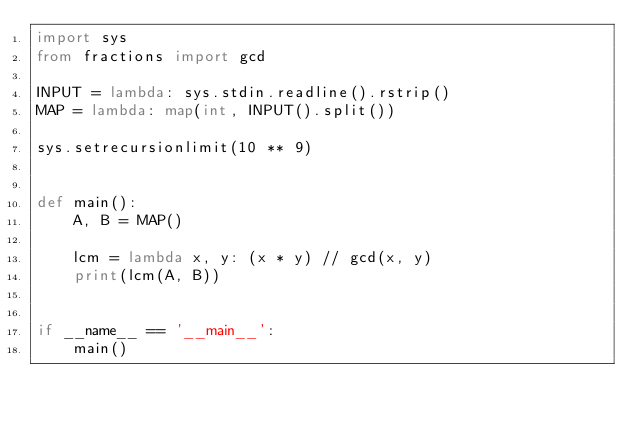Convert code to text. <code><loc_0><loc_0><loc_500><loc_500><_Python_>import sys
from fractions import gcd

INPUT = lambda: sys.stdin.readline().rstrip()
MAP = lambda: map(int, INPUT().split())

sys.setrecursionlimit(10 ** 9)


def main():
    A, B = MAP()
    
    lcm = lambda x, y: (x * y) // gcd(x, y)
    print(lcm(A, B))


if __name__ == '__main__':
    main()</code> 